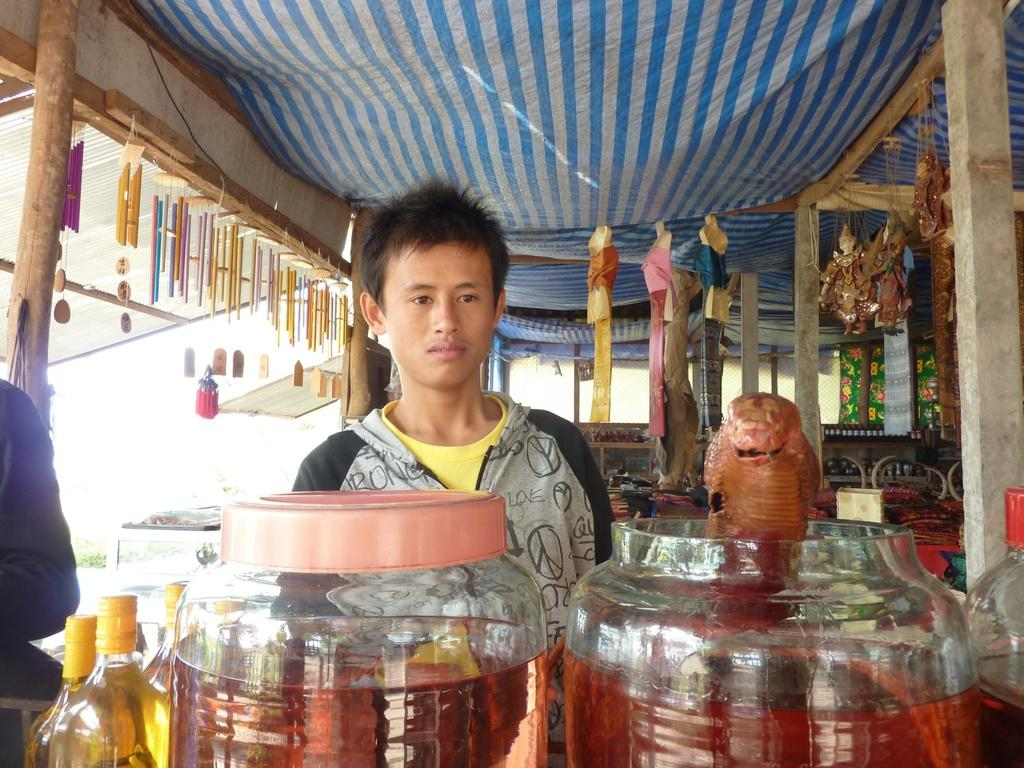What type of containers are visible in the image? There are jars and bottles in the image. What else can be seen in the image besides the containers? There is a person standing in the image. Where is the person standing in relation to the containers? The person is standing under a tent. How many cats are sitting on the jars in the image? There are no cats present in the image; it only features jars, bottles, a person, and a tent. 